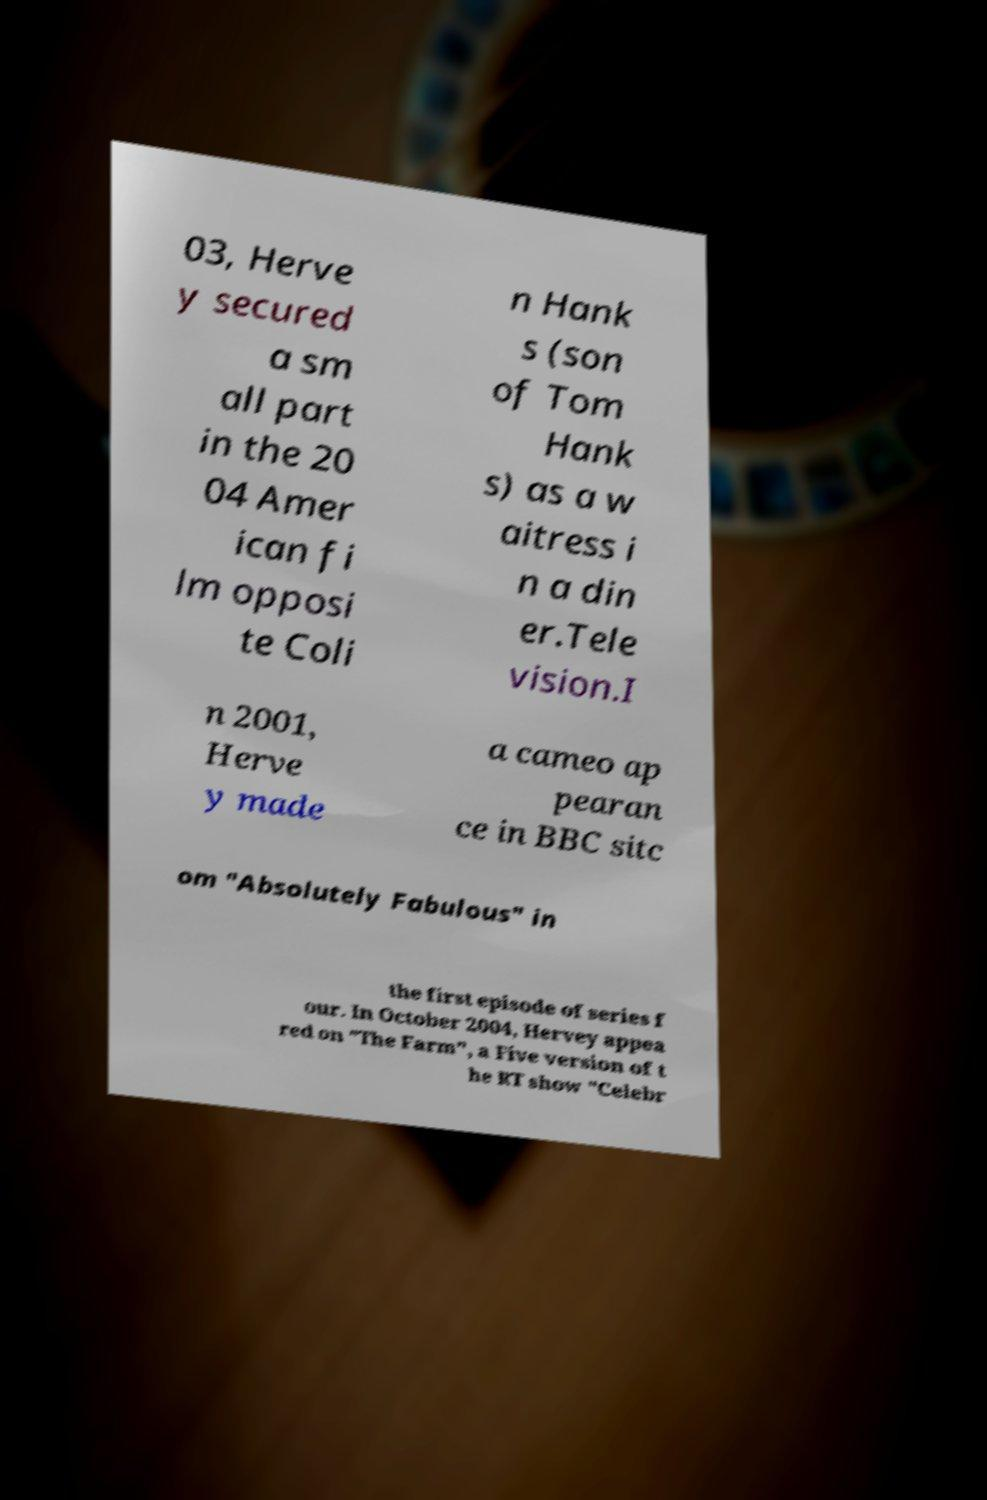I need the written content from this picture converted into text. Can you do that? 03, Herve y secured a sm all part in the 20 04 Amer ican fi lm opposi te Coli n Hank s (son of Tom Hank s) as a w aitress i n a din er.Tele vision.I n 2001, Herve y made a cameo ap pearan ce in BBC sitc om "Absolutely Fabulous" in the first episode of series f our. In October 2004, Hervey appea red on "The Farm", a Five version of t he RT show "Celebr 